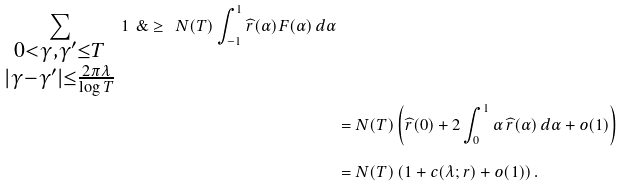<formula> <loc_0><loc_0><loc_500><loc_500>\sum _ { \substack { 0 < \gamma , \gamma ^ { \prime } \leq T \\ | \gamma - \gamma ^ { \prime } | \leq \frac { 2 \pi \lambda } { \log T } } } \, 1 \ \& \geq \ N ( T ) \int _ { - 1 } ^ { 1 } \widehat { r } ( \alpha ) F ( \alpha ) \, d \alpha \\ & = N ( T ) \left ( \widehat { r } ( 0 ) + 2 \int _ { 0 } ^ { 1 } \alpha \, \widehat { r } ( \alpha ) \, d \alpha + o ( 1 ) \right ) \\ & = N ( T ) \left ( 1 + c ( \lambda ; r ) + o ( 1 ) \right ) .</formula> 